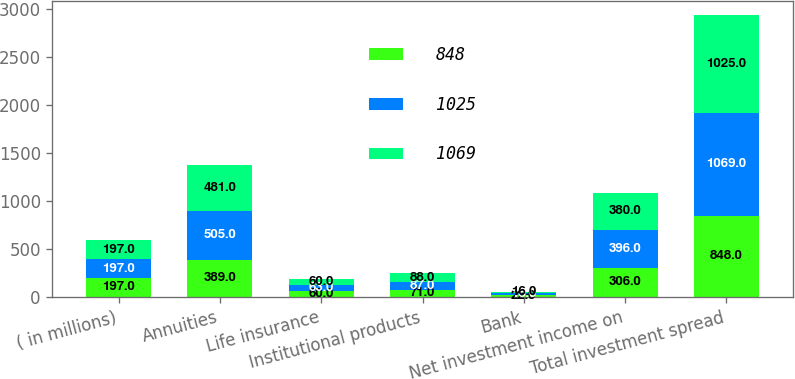Convert chart to OTSL. <chart><loc_0><loc_0><loc_500><loc_500><stacked_bar_chart><ecel><fcel>( in millions)<fcel>Annuities<fcel>Life insurance<fcel>Institutional products<fcel>Bank<fcel>Net investment income on<fcel>Total investment spread<nl><fcel>848<fcel>197<fcel>389<fcel>60<fcel>71<fcel>22<fcel>306<fcel>848<nl><fcel>1025<fcel>197<fcel>505<fcel>63<fcel>87<fcel>18<fcel>396<fcel>1069<nl><fcel>1069<fcel>197<fcel>481<fcel>60<fcel>88<fcel>16<fcel>380<fcel>1025<nl></chart> 